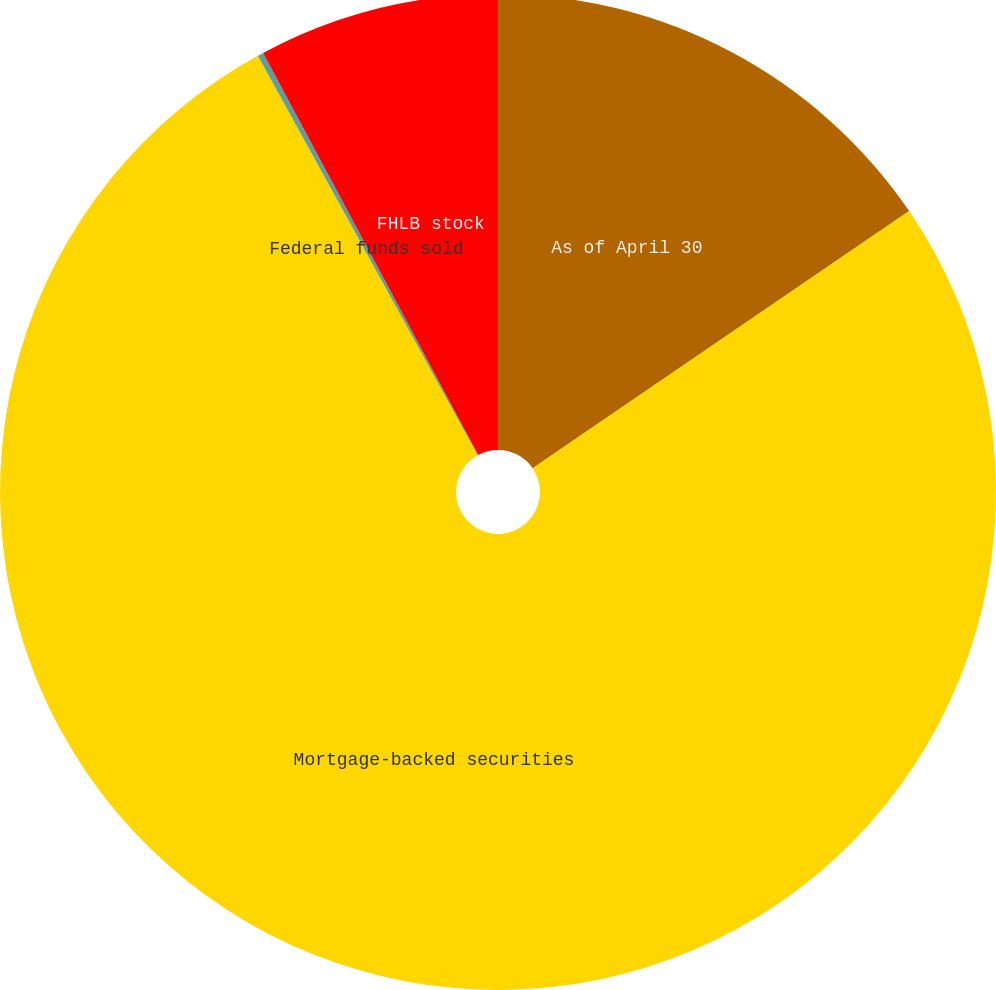Convert chart to OTSL. <chart><loc_0><loc_0><loc_500><loc_500><pie_chart><fcel>As of April 30<fcel>Mortgage-backed securities<fcel>Federal funds sold<fcel>FHLB stock<nl><fcel>15.46%<fcel>76.54%<fcel>0.19%<fcel>7.82%<nl></chart> 